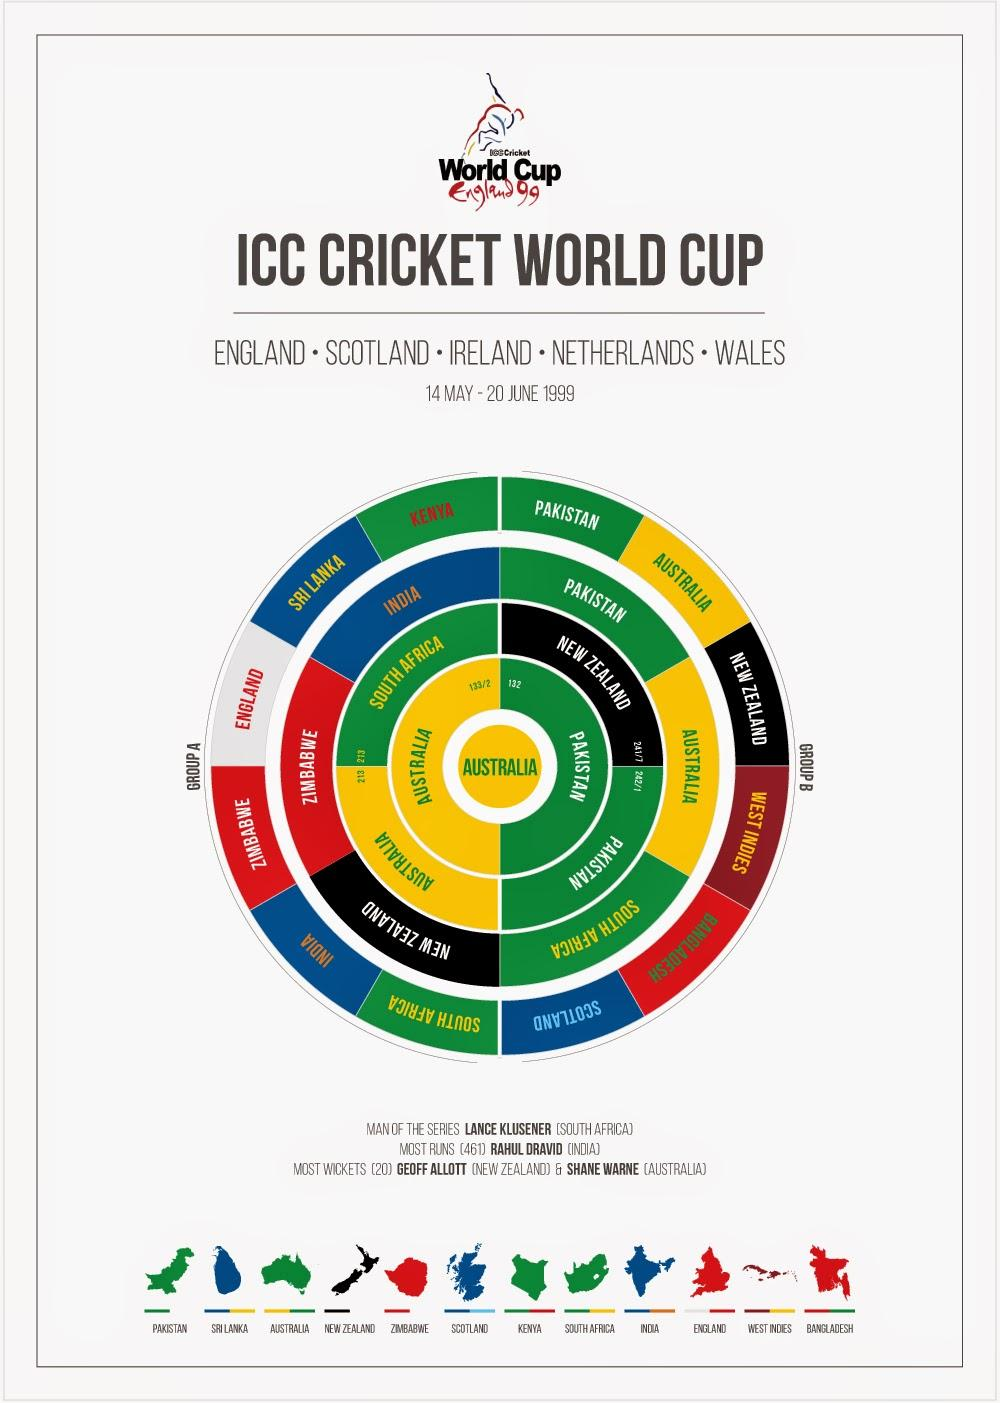Highlight a few significant elements in this photo. Out of the participating teams in the Quarterfinals, three teams came from each group. Australia's opponent in the semi-final was South Africa. The top scorer of the 1999 Cricket World Cup was Rahul Dravid. India's performance in the 1990 World Cup reached up to the quarter-finals stage. The color code given to Team South Africa is green. Yellow, blue, and black are also part of the Team South Africa's color scheme. 